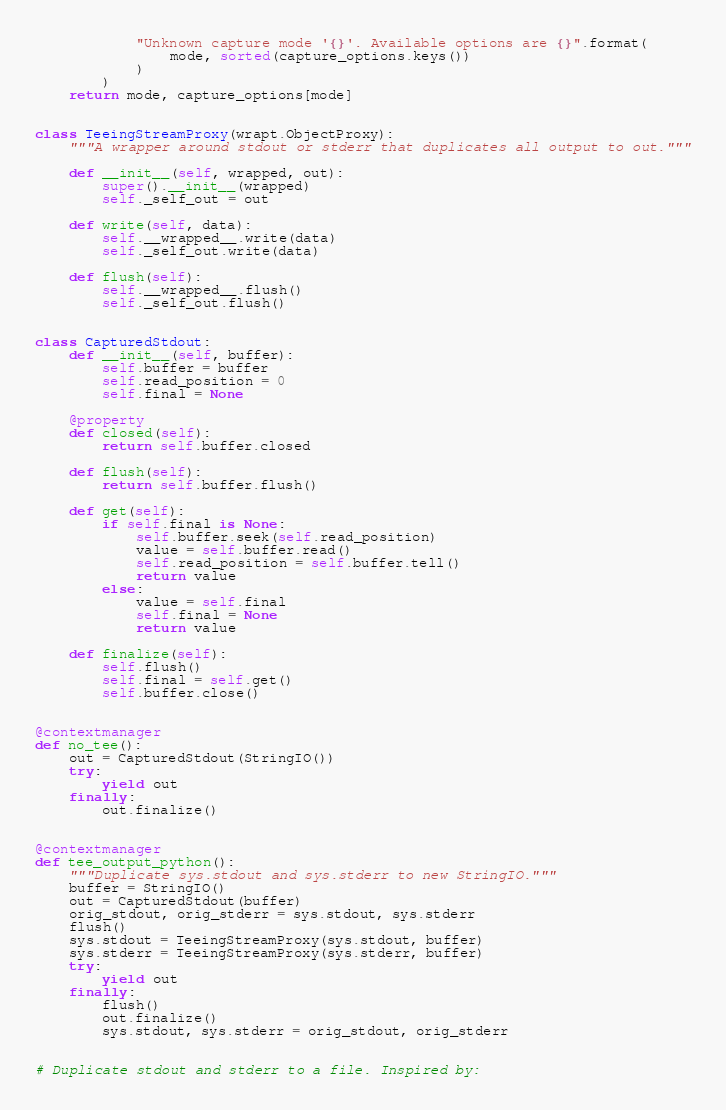<code> <loc_0><loc_0><loc_500><loc_500><_Python_>            "Unknown capture mode '{}'. Available options are {}".format(
                mode, sorted(capture_options.keys())
            )
        )
    return mode, capture_options[mode]


class TeeingStreamProxy(wrapt.ObjectProxy):
    """A wrapper around stdout or stderr that duplicates all output to out."""

    def __init__(self, wrapped, out):
        super().__init__(wrapped)
        self._self_out = out

    def write(self, data):
        self.__wrapped__.write(data)
        self._self_out.write(data)

    def flush(self):
        self.__wrapped__.flush()
        self._self_out.flush()


class CapturedStdout:
    def __init__(self, buffer):
        self.buffer = buffer
        self.read_position = 0
        self.final = None

    @property
    def closed(self):
        return self.buffer.closed

    def flush(self):
        return self.buffer.flush()

    def get(self):
        if self.final is None:
            self.buffer.seek(self.read_position)
            value = self.buffer.read()
            self.read_position = self.buffer.tell()
            return value
        else:
            value = self.final
            self.final = None
            return value

    def finalize(self):
        self.flush()
        self.final = self.get()
        self.buffer.close()


@contextmanager
def no_tee():
    out = CapturedStdout(StringIO())
    try:
        yield out
    finally:
        out.finalize()


@contextmanager
def tee_output_python():
    """Duplicate sys.stdout and sys.stderr to new StringIO."""
    buffer = StringIO()
    out = CapturedStdout(buffer)
    orig_stdout, orig_stderr = sys.stdout, sys.stderr
    flush()
    sys.stdout = TeeingStreamProxy(sys.stdout, buffer)
    sys.stderr = TeeingStreamProxy(sys.stderr, buffer)
    try:
        yield out
    finally:
        flush()
        out.finalize()
        sys.stdout, sys.stderr = orig_stdout, orig_stderr


# Duplicate stdout and stderr to a file. Inspired by:</code> 